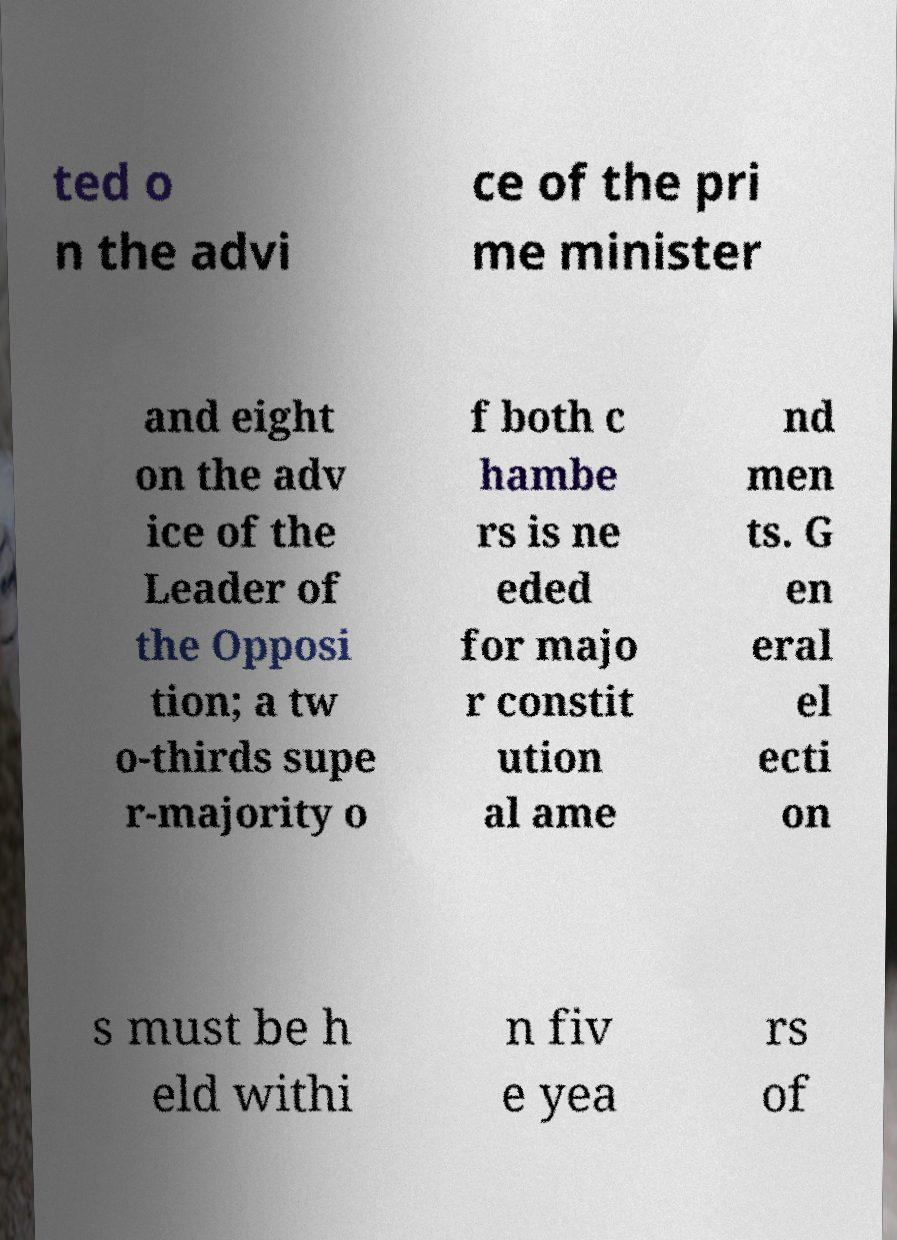What is the topic of the text in this image? The topic seems to be related to governance or political procedures, specifically regarding the appointment of officials and constitutional amendment processes. 